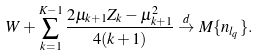Convert formula to latex. <formula><loc_0><loc_0><loc_500><loc_500>W + \sum _ { k = 1 } ^ { K - 1 } \frac { 2 \mu _ { k + 1 } Z _ { k } - \mu _ { k + 1 } ^ { 2 } } { 4 ( k + 1 ) } \stackrel { d } { \to } M \{ n _ { l _ { q } } \} .</formula> 